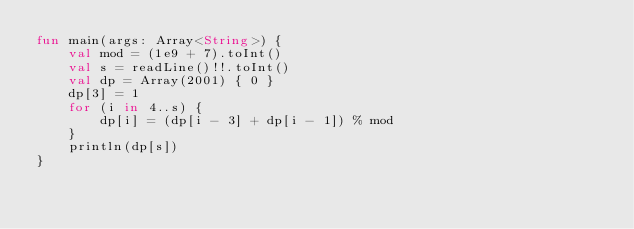Convert code to text. <code><loc_0><loc_0><loc_500><loc_500><_Kotlin_>fun main(args: Array<String>) {
    val mod = (1e9 + 7).toInt()
    val s = readLine()!!.toInt()
    val dp = Array(2001) { 0 }
    dp[3] = 1
    for (i in 4..s) {
        dp[i] = (dp[i - 3] + dp[i - 1]) % mod
    }
    println(dp[s])
}</code> 